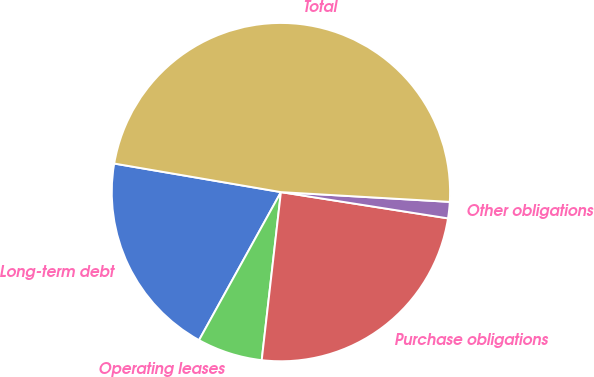Convert chart to OTSL. <chart><loc_0><loc_0><loc_500><loc_500><pie_chart><fcel>Long-term debt<fcel>Operating leases<fcel>Purchase obligations<fcel>Other obligations<fcel>Total<nl><fcel>19.66%<fcel>6.23%<fcel>24.33%<fcel>1.56%<fcel>48.22%<nl></chart> 